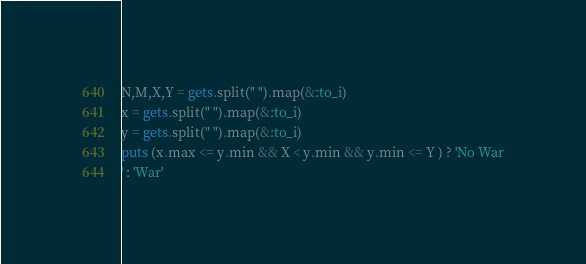<code> <loc_0><loc_0><loc_500><loc_500><_Ruby_>N,M,X,Y = gets.split(" ").map(&:to_i)
x = gets.split(" ").map(&:to_i)
y = gets.split(" ").map(&:to_i)
puts (x.max <= y.min && X < y.min && y.min <= Y ) ? 'No War
' : 'War'</code> 